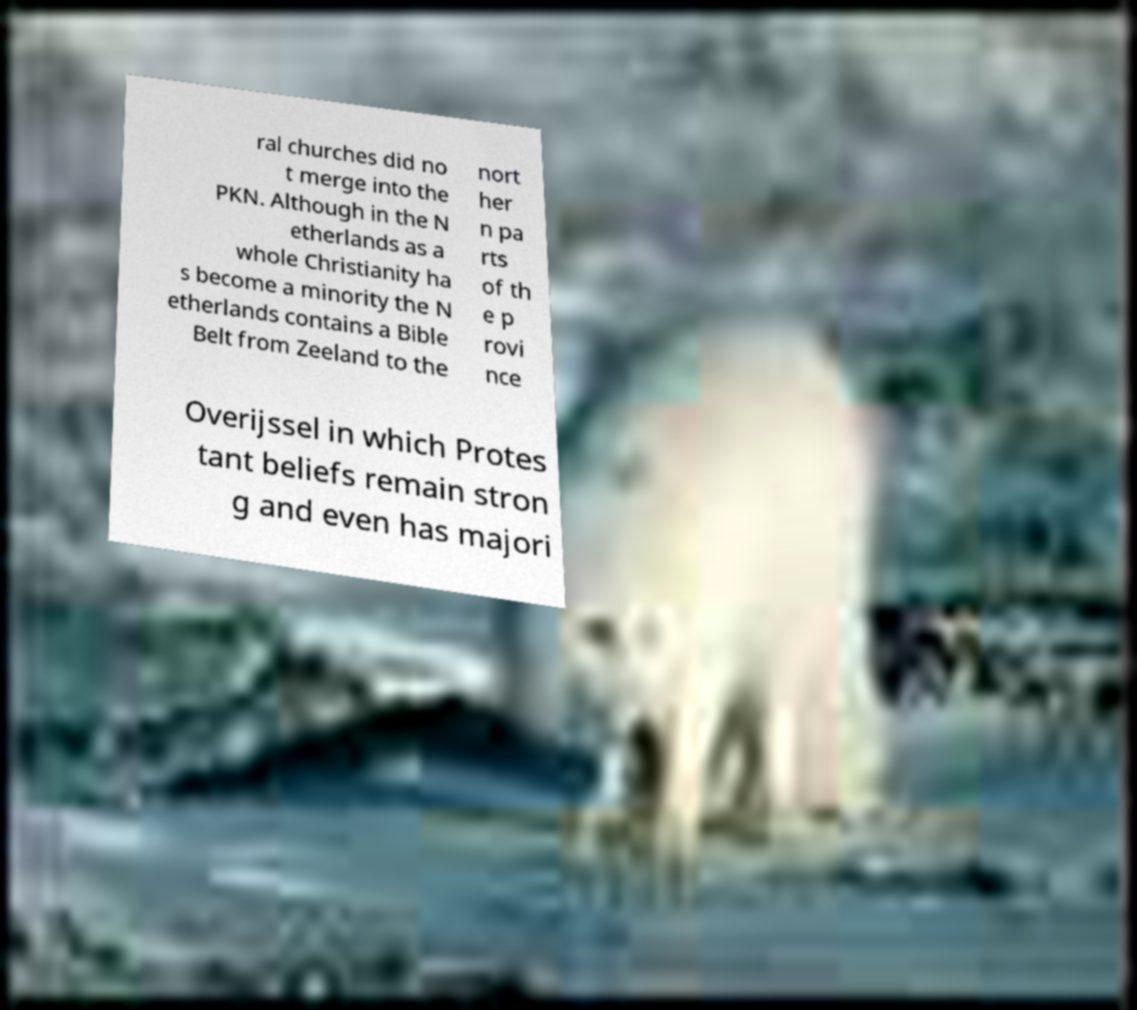Could you extract and type out the text from this image? ral churches did no t merge into the PKN. Although in the N etherlands as a whole Christianity ha s become a minority the N etherlands contains a Bible Belt from Zeeland to the nort her n pa rts of th e p rovi nce Overijssel in which Protes tant beliefs remain stron g and even has majori 